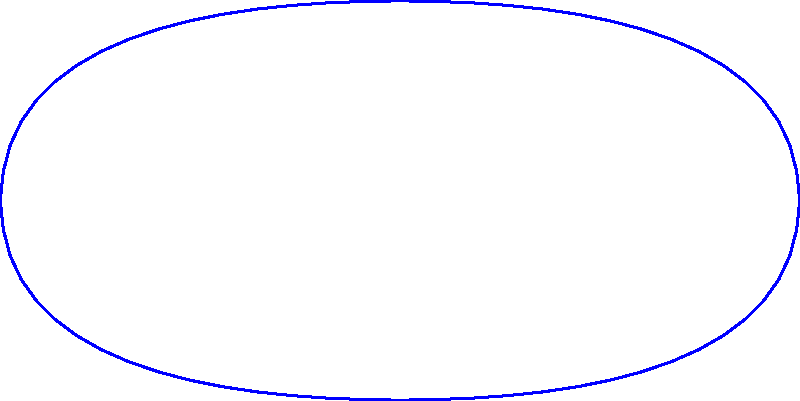Based on the dihedral group representation of Copionodon pecten's fin patterns shown in the diagram, how many elements are in the symmetry group of the fish's fin arrangement, and what is the order of rotation $r$ in this group? To answer this question, let's analyze the diagram step-by-step:

1. The diagram shows a fish outline with fin patterns represented using the dihedral group D4.

2. In the dihedral group D4, there are two types of symmetries:
   a) Rotations ($r_0$, $r_1$, $r_2$, $r_3$)
   b) Reflections ($s_0$, $s_1$, $s_2$, $s_3$)

3. Counting the elements:
   - 4 rotations (including the identity rotation $r_0$)
   - 4 reflections

4. The total number of elements in the symmetry group is 4 + 4 = 8.

5. To find the order of rotation $r$, we need to determine how many rotations are needed to return to the original position.

6. From the diagram, we can see that there are 4 distinct rotations ($r_0$, $r_1$, $r_2$, $r_3$), each representing a 90° rotation.

7. This means that after 4 rotations of 90°, we return to the original position.

Therefore, the symmetry group has 8 elements, and the order of rotation $r$ is 4.
Answer: 8 elements; order of $r$ is 4 